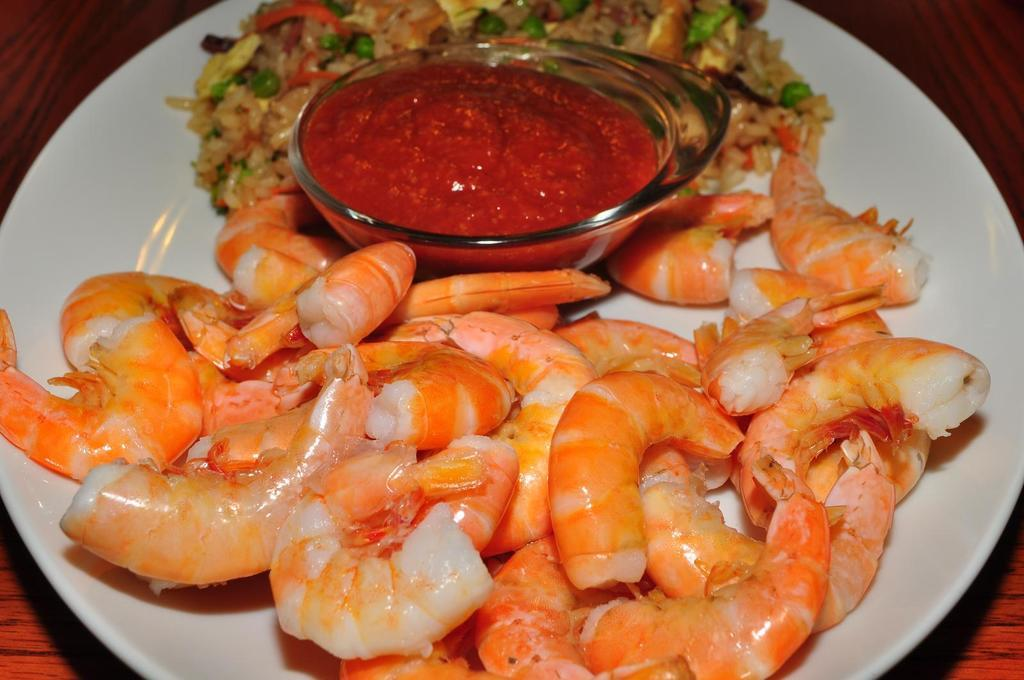What is the main object in the center of the image? There is a table in the center of the image. What type of food is on the table? A plate of prawns, a bowl of ketchup, and fried rice are present on the table. Can you describe the arrangement of the food on the table? The plate of prawns, bowl of ketchup, and fried rice are all on the table. How many feathers are on the plate of prawns? There are no feathers present on the plate of prawns; it contains only prawns. Can you tell me how much sugar is in the fried rice? There is no mention of sugar in the fried rice, and it is not visible in the image. 